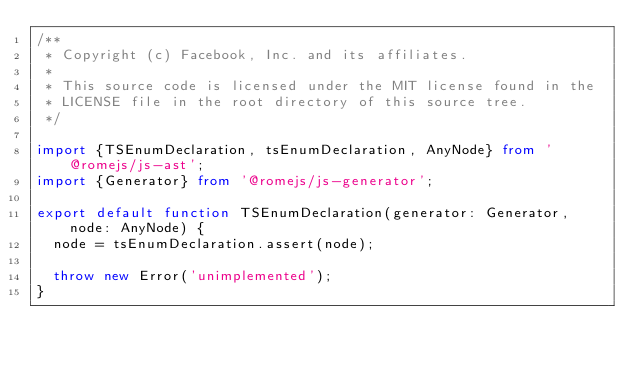Convert code to text. <code><loc_0><loc_0><loc_500><loc_500><_TypeScript_>/**
 * Copyright (c) Facebook, Inc. and its affiliates.
 *
 * This source code is licensed under the MIT license found in the
 * LICENSE file in the root directory of this source tree.
 */

import {TSEnumDeclaration, tsEnumDeclaration, AnyNode} from '@romejs/js-ast';
import {Generator} from '@romejs/js-generator';

export default function TSEnumDeclaration(generator: Generator, node: AnyNode) {
  node = tsEnumDeclaration.assert(node);

  throw new Error('unimplemented');
}
</code> 